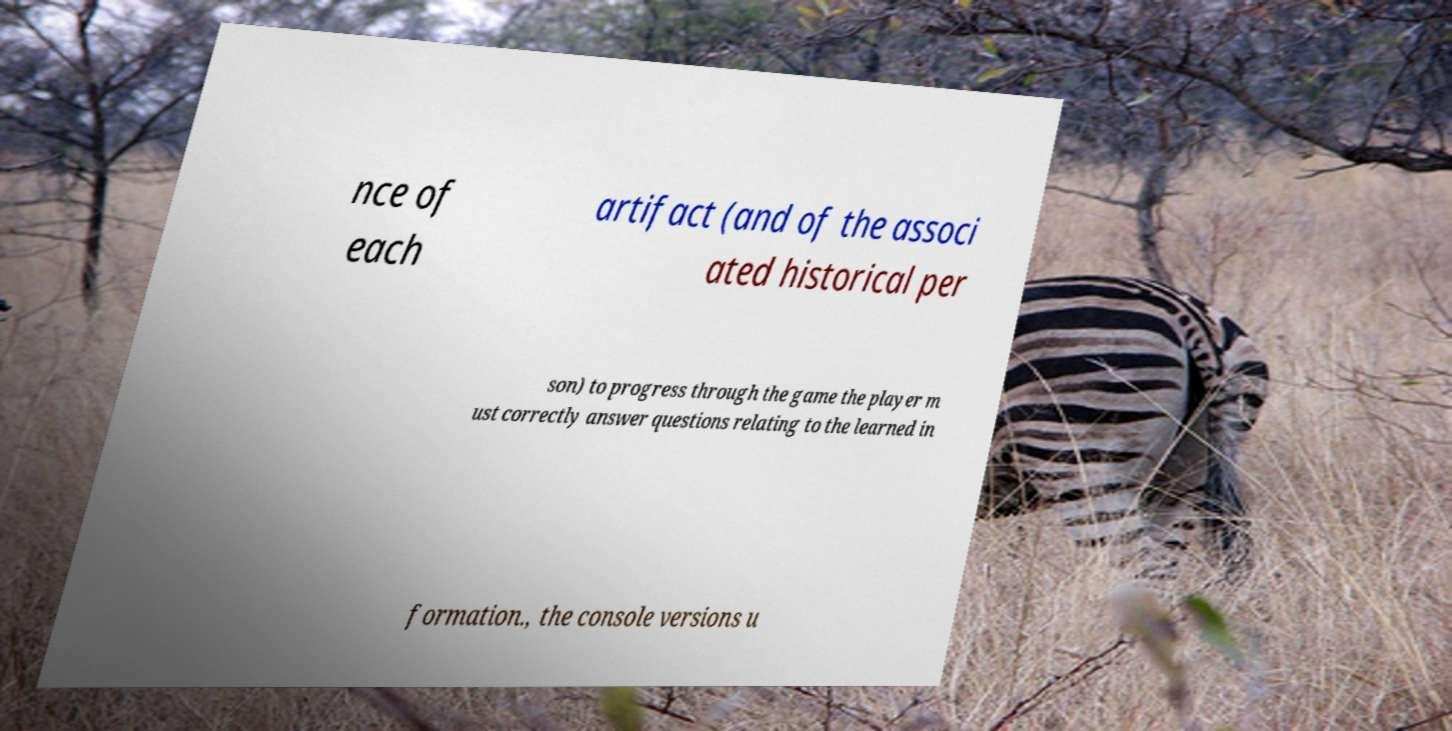Please identify and transcribe the text found in this image. nce of each artifact (and of the associ ated historical per son) to progress through the game the player m ust correctly answer questions relating to the learned in formation., the console versions u 